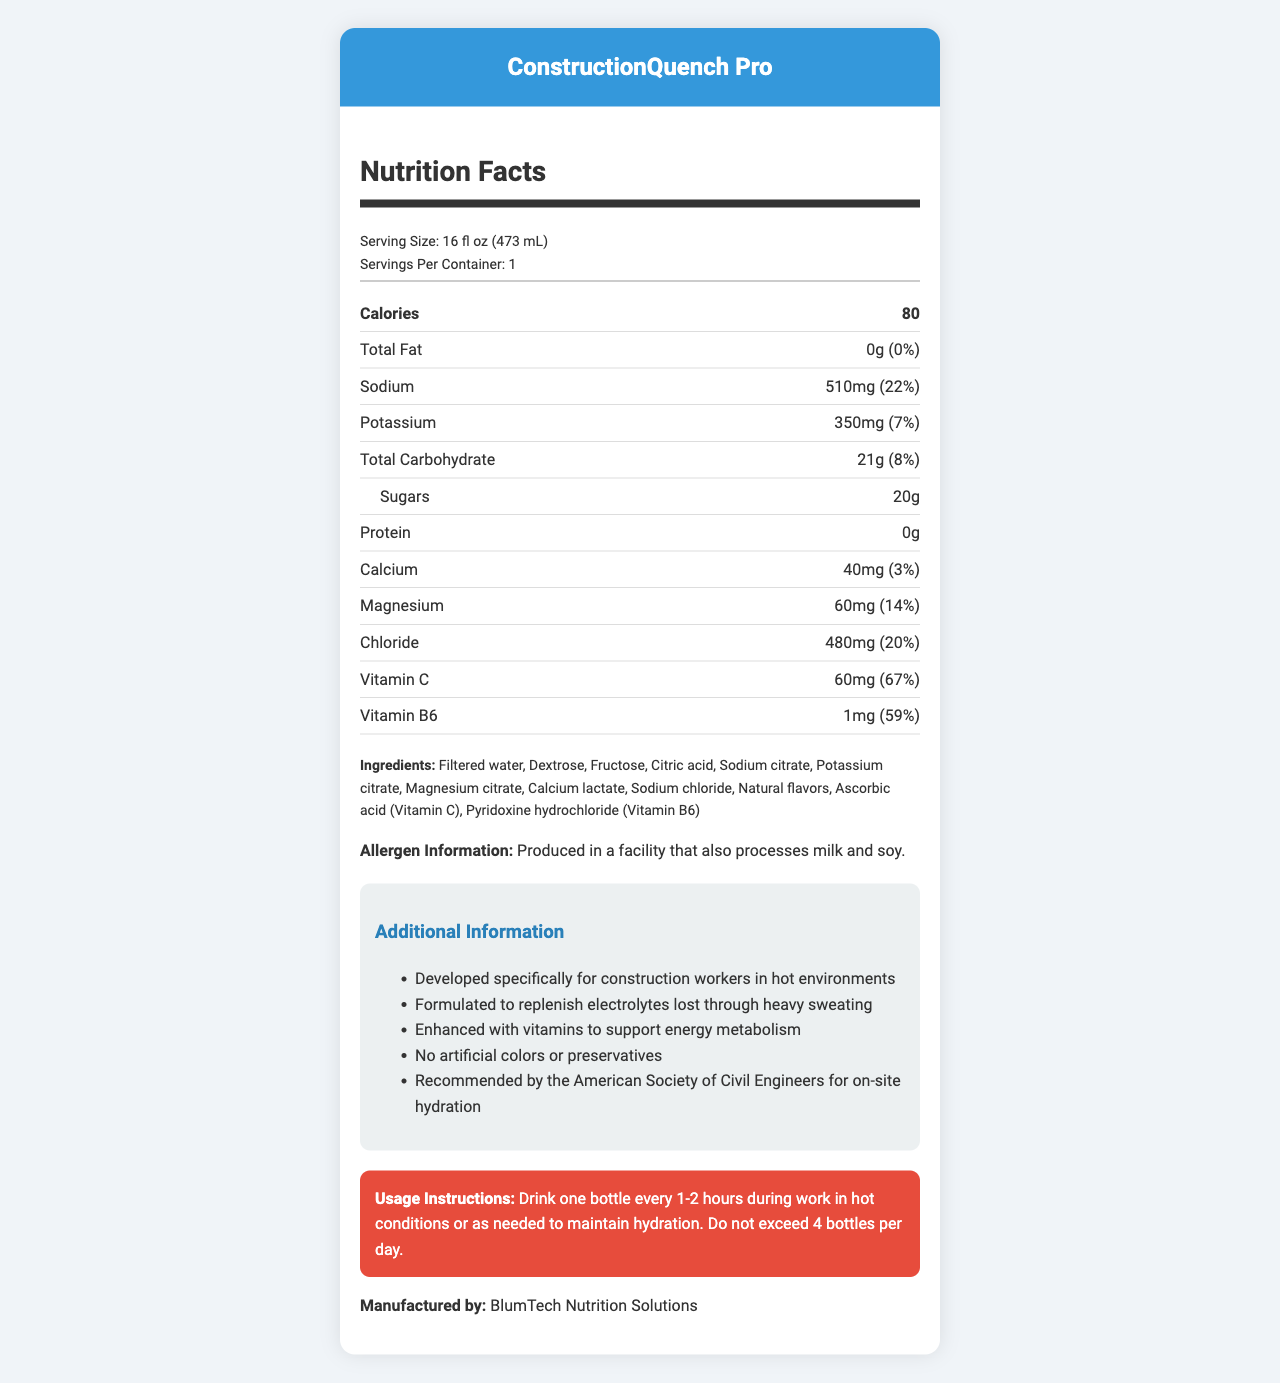what is the product name? The product name is displayed prominently at the top of the document.
Answer: ConstructionQuench Pro what is the serving size and servings per container? The serving size and servings per container are listed in the "Serving Size" section.
Answer: 16 fl oz (473 mL), 1 how much sodium does this drink contain per serving? The sodium content per serving is listed in the "Sodium" section.
Answer: 510mg what percentage of the daily value of Vitamin C does this drink provide? This information is found in the "Vitamin C" section.
Answer: 67% what ingredient comes first in the list of ingredients? The first ingredient in the list is "Filtered water," as seen in the Ingredients section.
Answer: Filtered water what is the calorie content per serving? A. 50 B. 80 C. 100 The calorie content per serving is clearly listed in the "Calories" section.
Answer: B what manufacturer produces this electrolyte drink? A. BlumTech Nutrition Solutions B. Hydratech Industries C. Electrolyte Supplements Inc. The manufacturer is listed in the document as BlumTech Nutrition Solutions.
Answer: A does the drink contain any artificial colors or preservatives? In the additional information section, it states there are no artificial colors or preservatives.
Answer: No should you drink more than 4 bottles of this drink per day? True or False The usage instructions explicitly state not to exceed 4 bottles per day.
Answer: False summarize the main purpose of this document. The document includes nutrition facts, ingredients, allergen information, manufacturer details, additional benefits, and usage instructions for ConstructionQuench Pro.
Answer: The document provides detailed nutrition information and usage instructions for ConstructionQuench Pro, an electrolyte drink designed for construction workers in hot environments. It highlights the content of various nutrients, ingredients, and allergen information, as well as the product's benefits for hydration and energy metabolism. how much protein is in this drink? The protein content is listed as 0g in the "Protein" section.
Answer: 0g what percentage of the daily value of calcium does this drink provide? This information is provided in the "Calcium" section.
Answer: 3% what is the primary purpose of this electrolyte drink? This information is found in the additional information section, which details the product's purpose.
Answer: To replenish electrolytes lost through heavy sweating in hot construction environments is this drink recommended for energy metabolism support? The additional information mentions that the drink is enhanced with vitamins to support energy metabolism.
Answer: Yes who recommends this drink for on-site hydration? This is stated in the additional information section, mentioning the recommendation by the American Society of Civil Engineers.
Answer: The American Society of Civil Engineers what is the main source of sugars in this drink? These ingredients are listed early in the ingredients section as sources of sugars.
Answer: Dextrose and Fructose what types of allergens are processed in the facility where this drink is produced? The allergen information states that the facility also processes milk and soy.
Answer: Milk and soy what is the total amount of carbohydrates in this drink, and what percentage of the daily value does it provide? The total carbohydrate content and its daily value percentage are listed in the "Total Carbohydrate" section.
Answer: 21g, 8% what does the document not provide information about? A. Calories B. Manufacturer C. Price The document does not mention the price of the product.
Answer: C. Price 